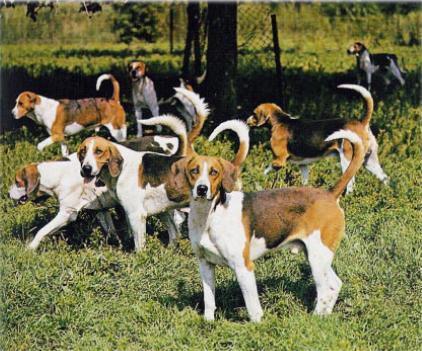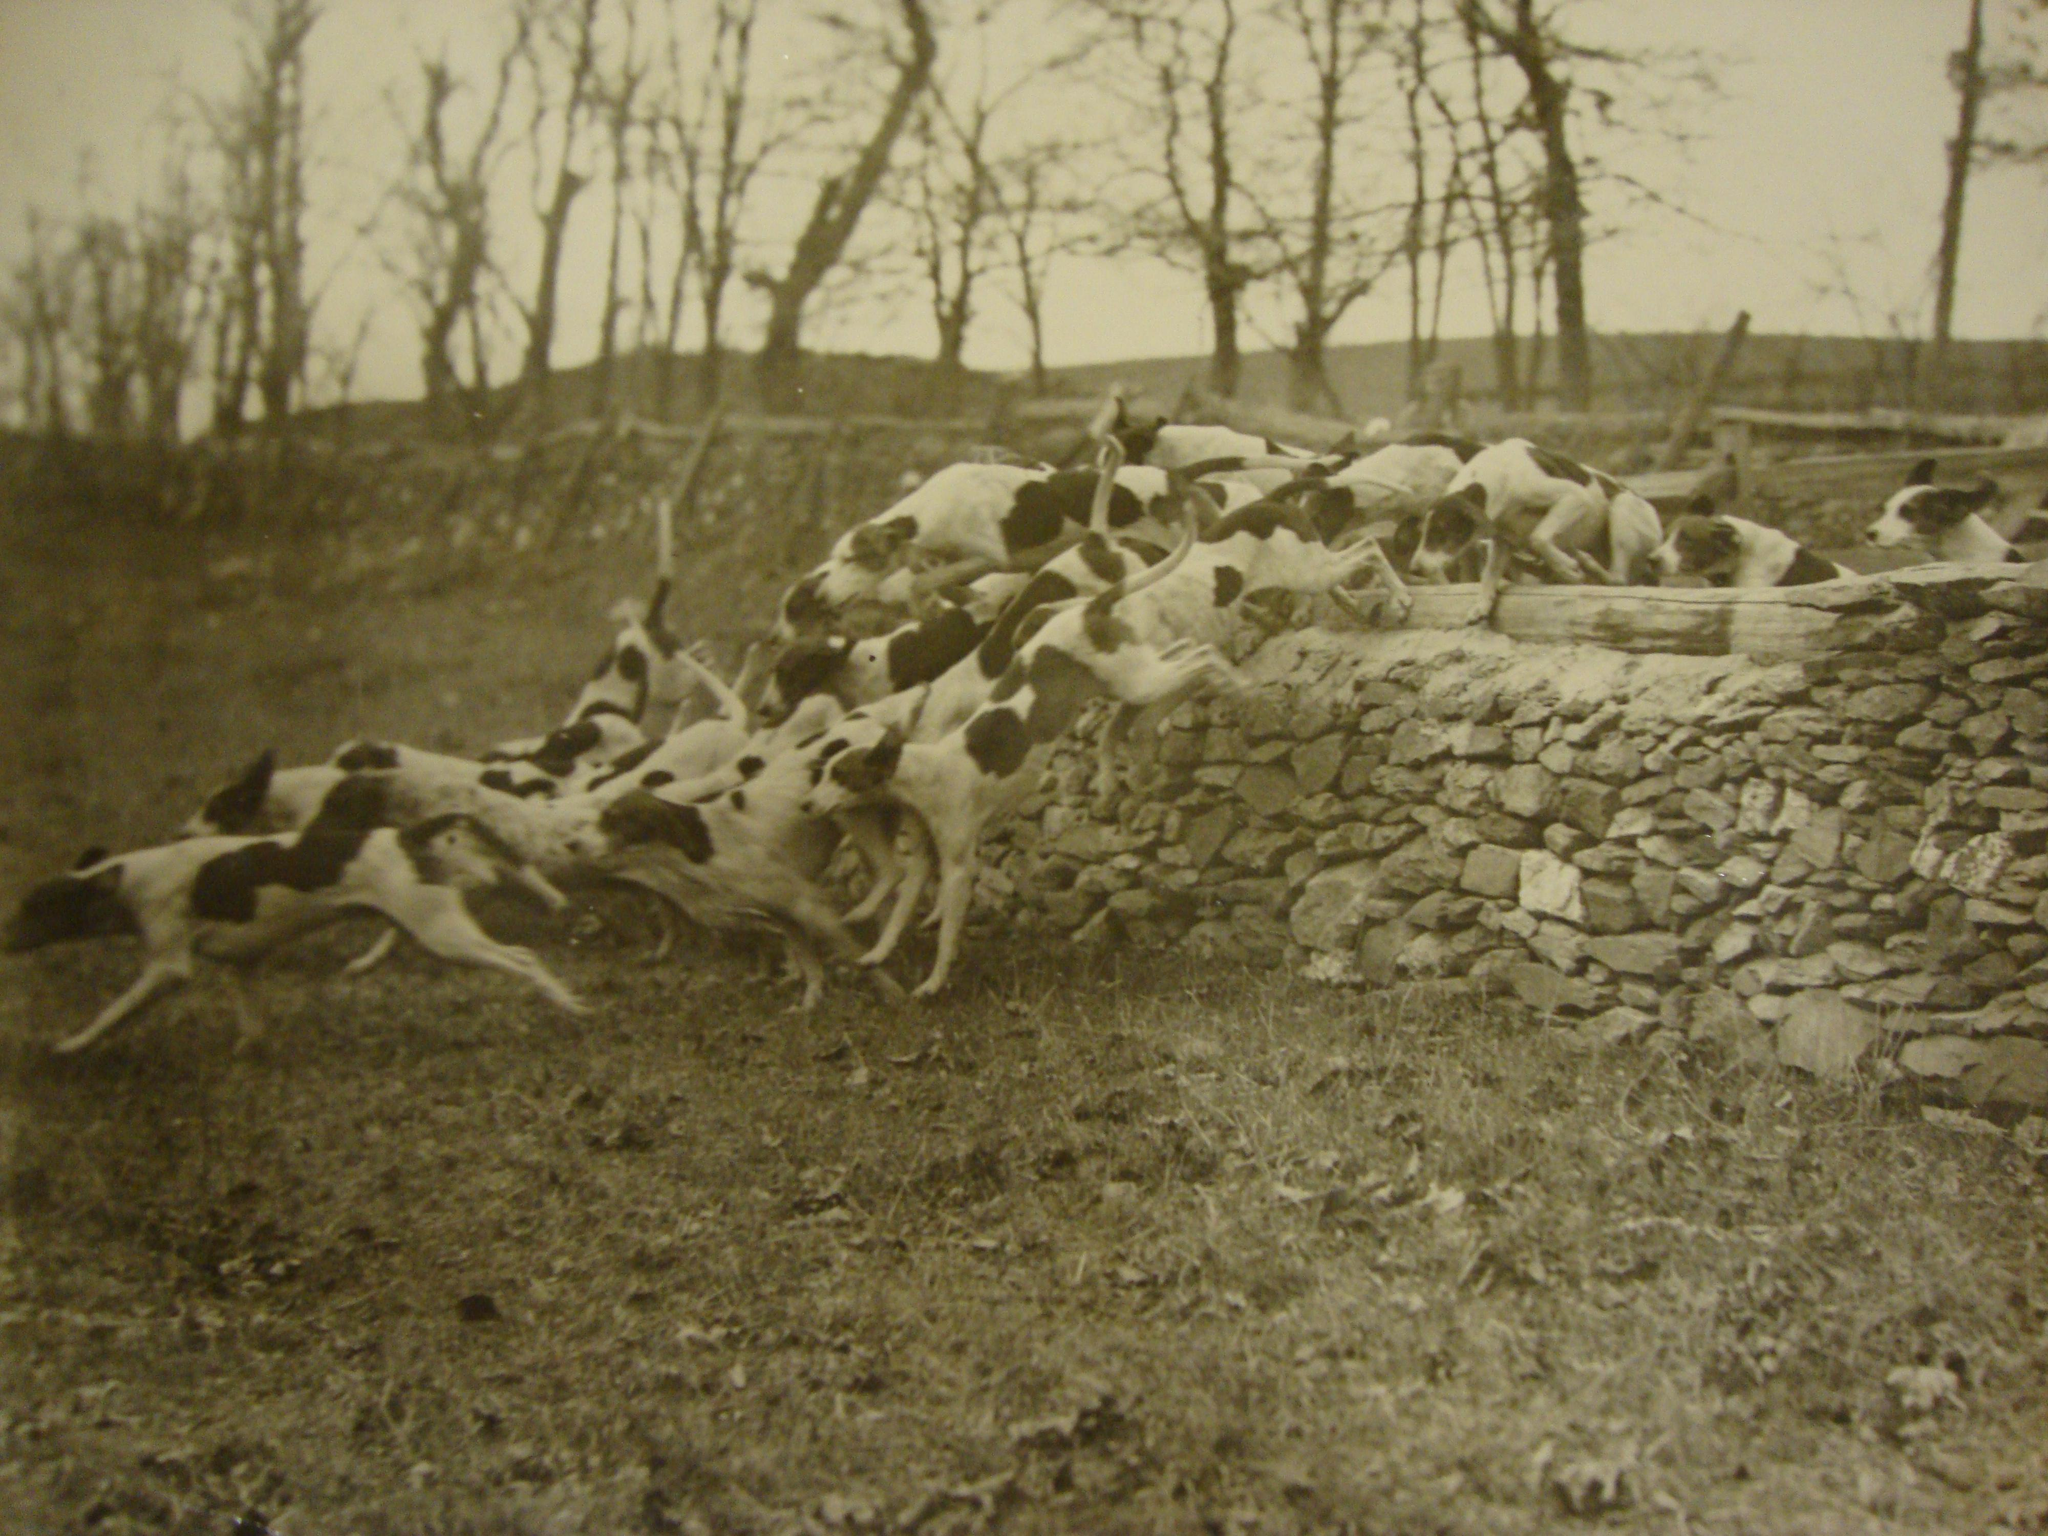The first image is the image on the left, the second image is the image on the right. Given the left and right images, does the statement "There is exactly one dog in one of the images." hold true? Answer yes or no. No. 